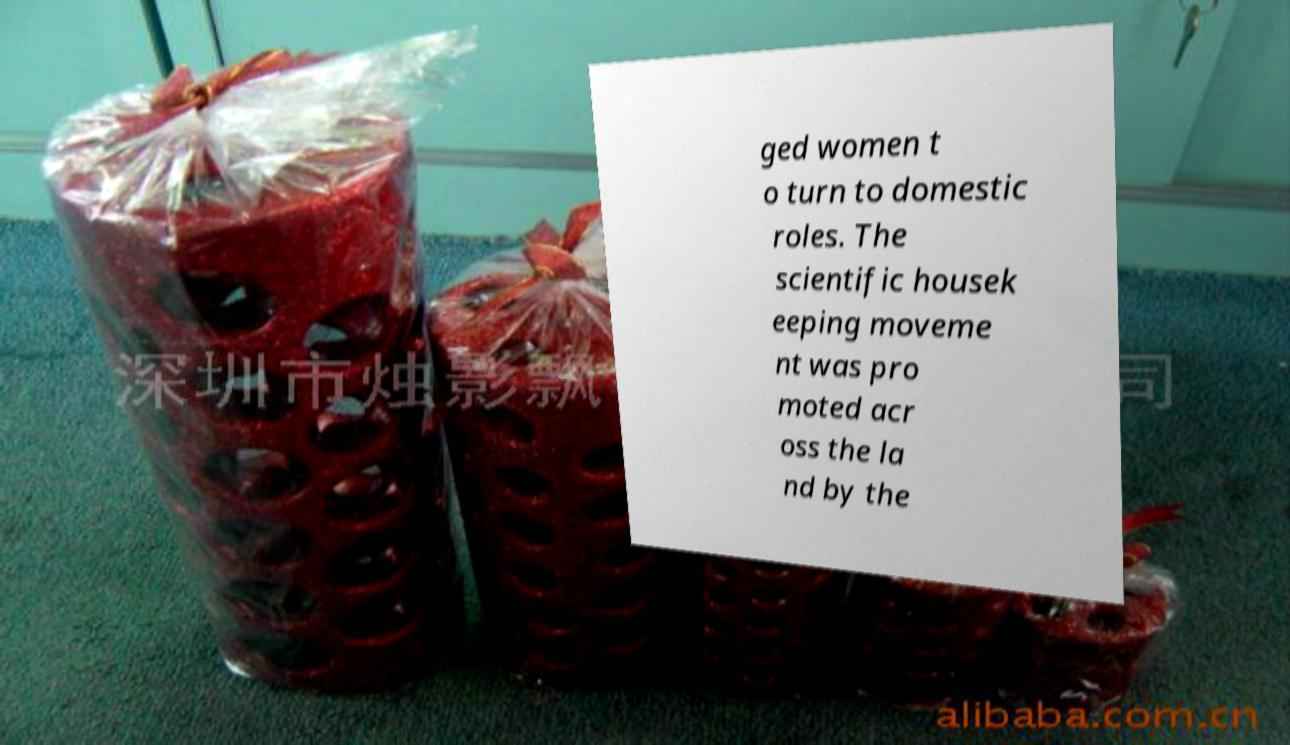Can you accurately transcribe the text from the provided image for me? ged women t o turn to domestic roles. The scientific housek eeping moveme nt was pro moted acr oss the la nd by the 